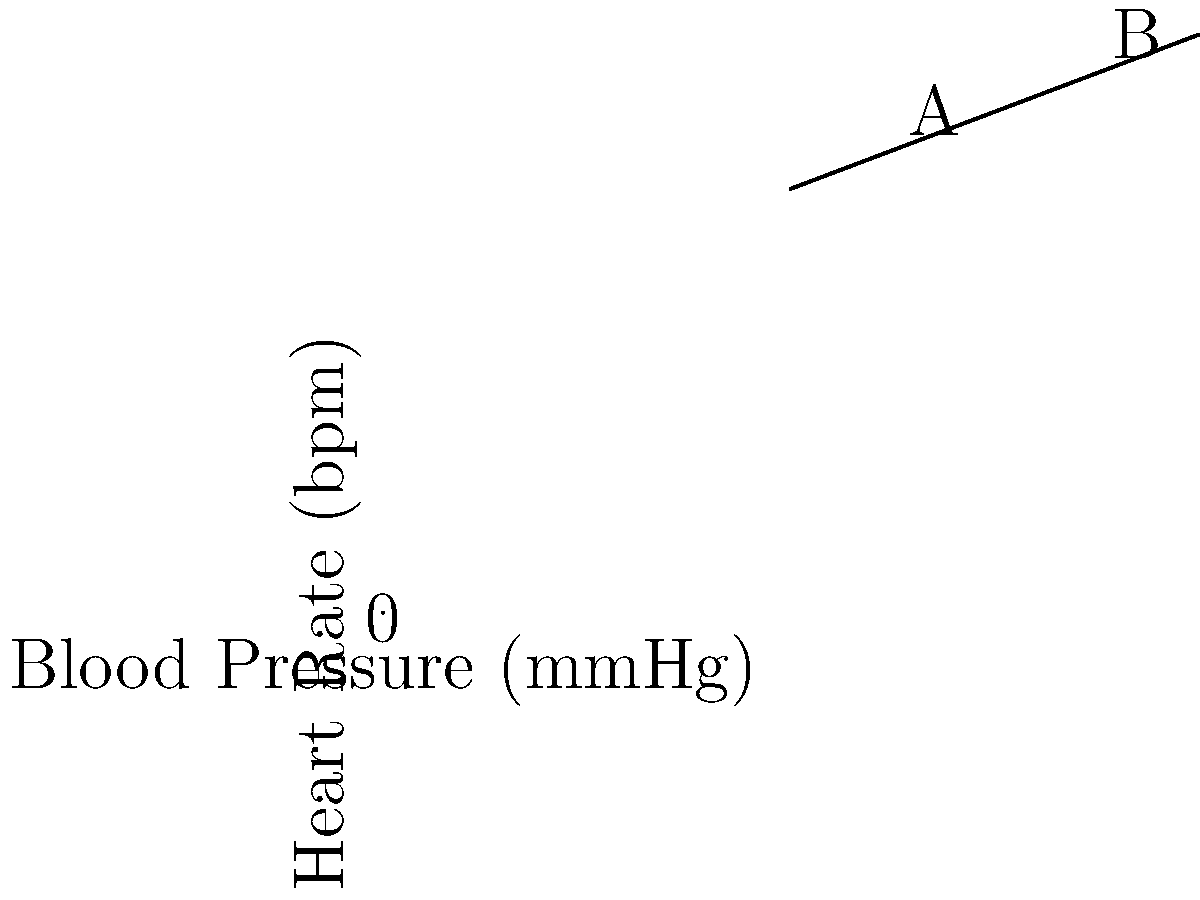The graph shows the relationship between blood pressure and heart rate for a patient during a stress test. What is the approximate increase in heart rate (in beats per minute) when the blood pressure increases from point A (100 mmHg) to point B (140 mmHg)? To solve this problem, we need to follow these steps:

1. Identify the heart rate at point A (100 mmHg):
   At point A, the heart rate is approximately 120 bpm.

2. Identify the heart rate at point B (140 mmHg):
   At point B, the heart rate is approximately 140 bpm.

3. Calculate the difference in heart rate:
   $\text{Increase in heart rate} = \text{Heart rate at B} - \text{Heart rate at A}$
   $\text{Increase in heart rate} = 140 \text{ bpm} - 120 \text{ bpm} = 20 \text{ bpm}$

The graph shows a linear relationship between blood pressure and heart rate. The increase in heart rate is consistent with the physiological response to increased blood pressure during a stress test, where the sympathetic nervous system is activated.
Answer: 20 bpm 